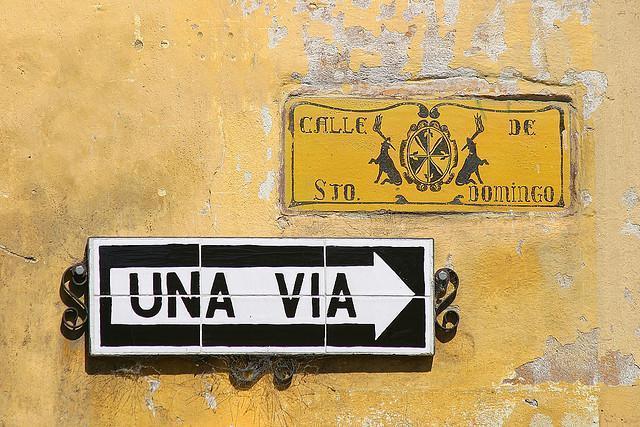How many signs are there?
Give a very brief answer. 2. 